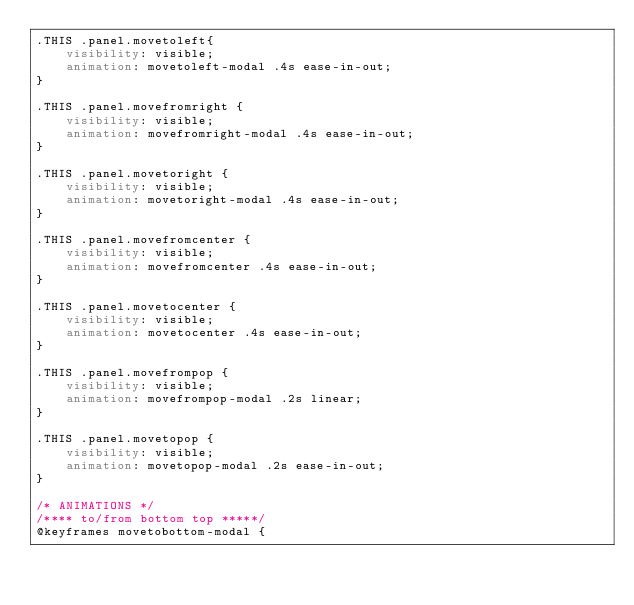Convert code to text. <code><loc_0><loc_0><loc_500><loc_500><_CSS_>.THIS .panel.movetoleft{
    visibility: visible;
    animation: movetoleft-modal .4s ease-in-out;
}

.THIS .panel.movefromright {
    visibility: visible;
    animation: movefromright-modal .4s ease-in-out;
}

.THIS .panel.movetoright {
    visibility: visible;
    animation: movetoright-modal .4s ease-in-out;
}

.THIS .panel.movefromcenter {
    visibility: visible;
    animation: movefromcenter .4s ease-in-out;
}

.THIS .panel.movetocenter {
    visibility: visible;
    animation: movetocenter .4s ease-in-out;
}

.THIS .panel.movefrompop {
    visibility: visible;
    animation: movefrompop-modal .2s linear;
}

.THIS .panel.movetopop {
    visibility: visible;
    animation: movetopop-modal .2s ease-in-out;
}

/* ANIMATIONS */
/**** to/from bottom top *****/
@keyframes movetobottom-modal {</code> 